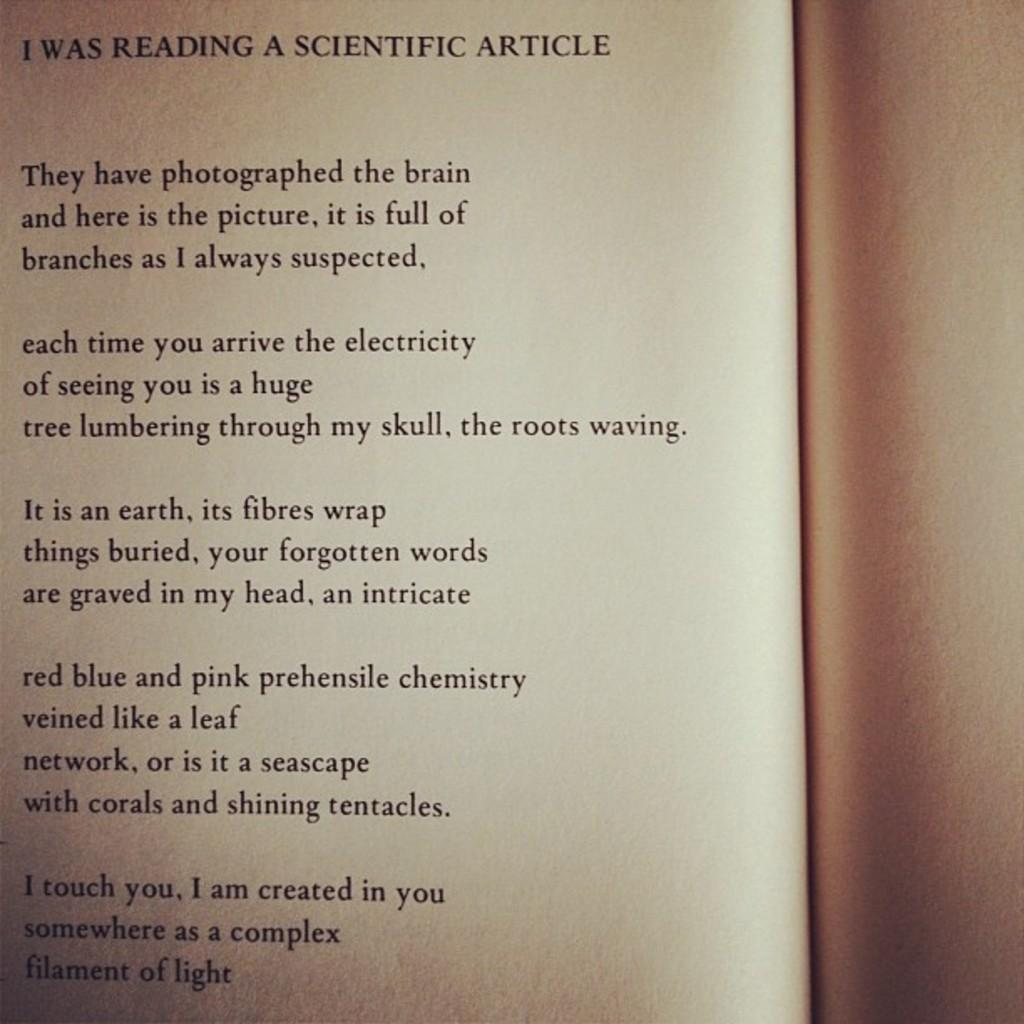<image>
Describe the image concisely. THE PAGE OF A BOOK WITH PARAGRAPHS OF POETRY 